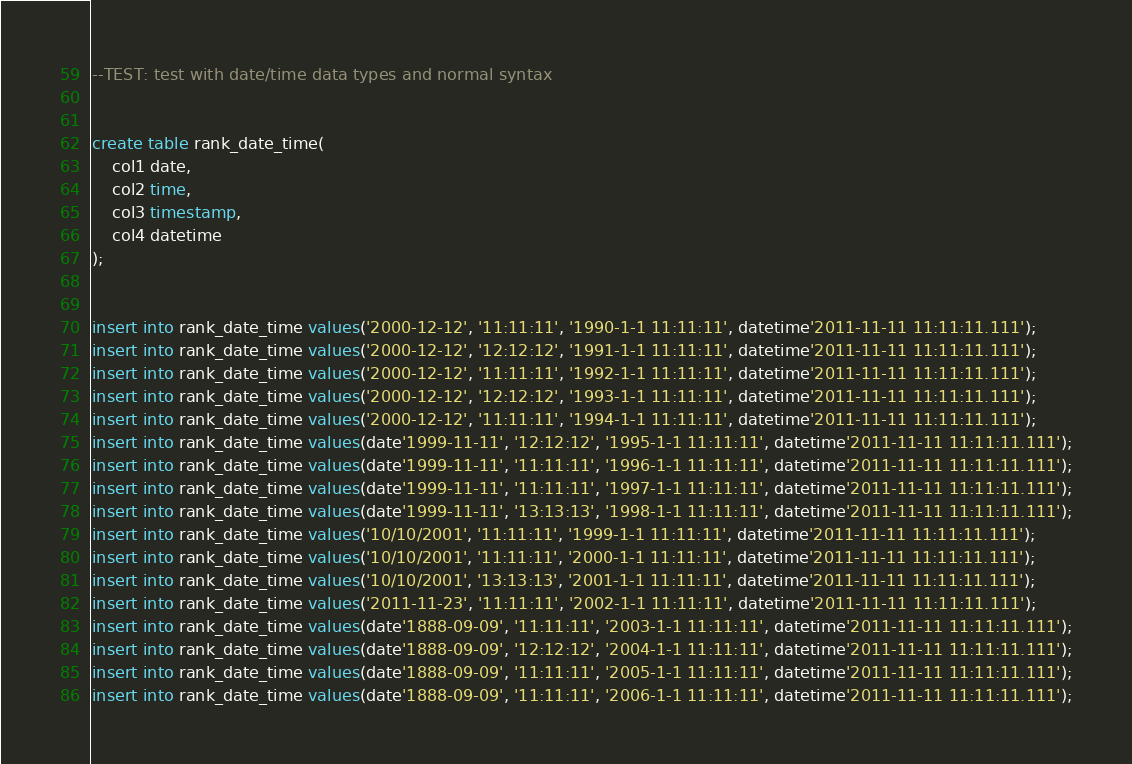<code> <loc_0><loc_0><loc_500><loc_500><_SQL_>--TEST: test with date/time data types and normal syntax


create table rank_date_time(
	col1 date,
	col2 time, 
	col3 timestamp,
	col4 datetime
);


insert into rank_date_time values('2000-12-12', '11:11:11', '1990-1-1 11:11:11', datetime'2011-11-11 11:11:11.111');
insert into rank_date_time values('2000-12-12', '12:12:12', '1991-1-1 11:11:11', datetime'2011-11-11 11:11:11.111');
insert into rank_date_time values('2000-12-12', '11:11:11', '1992-1-1 11:11:11', datetime'2011-11-11 11:11:11.111');
insert into rank_date_time values('2000-12-12', '12:12:12', '1993-1-1 11:11:11', datetime'2011-11-11 11:11:11.111');
insert into rank_date_time values('2000-12-12', '11:11:11', '1994-1-1 11:11:11', datetime'2011-11-11 11:11:11.111');
insert into rank_date_time values(date'1999-11-11', '12:12:12', '1995-1-1 11:11:11', datetime'2011-11-11 11:11:11.111');
insert into rank_date_time values(date'1999-11-11', '11:11:11', '1996-1-1 11:11:11', datetime'2011-11-11 11:11:11.111');
insert into rank_date_time values(date'1999-11-11', '11:11:11', '1997-1-1 11:11:11', datetime'2011-11-11 11:11:11.111');
insert into rank_date_time values(date'1999-11-11', '13:13:13', '1998-1-1 11:11:11', datetime'2011-11-11 11:11:11.111');
insert into rank_date_time values('10/10/2001', '11:11:11', '1999-1-1 11:11:11', datetime'2011-11-11 11:11:11.111');
insert into rank_date_time values('10/10/2001', '11:11:11', '2000-1-1 11:11:11', datetime'2011-11-11 11:11:11.111');
insert into rank_date_time values('10/10/2001', '13:13:13', '2001-1-1 11:11:11', datetime'2011-11-11 11:11:11.111');
insert into rank_date_time values('2011-11-23', '11:11:11', '2002-1-1 11:11:11', datetime'2011-11-11 11:11:11.111');
insert into rank_date_time values(date'1888-09-09', '11:11:11', '2003-1-1 11:11:11', datetime'2011-11-11 11:11:11.111');
insert into rank_date_time values(date'1888-09-09', '12:12:12', '2004-1-1 11:11:11', datetime'2011-11-11 11:11:11.111');
insert into rank_date_time values(date'1888-09-09', '11:11:11', '2005-1-1 11:11:11', datetime'2011-11-11 11:11:11.111');
insert into rank_date_time values(date'1888-09-09', '11:11:11', '2006-1-1 11:11:11', datetime'2011-11-11 11:11:11.111');</code> 